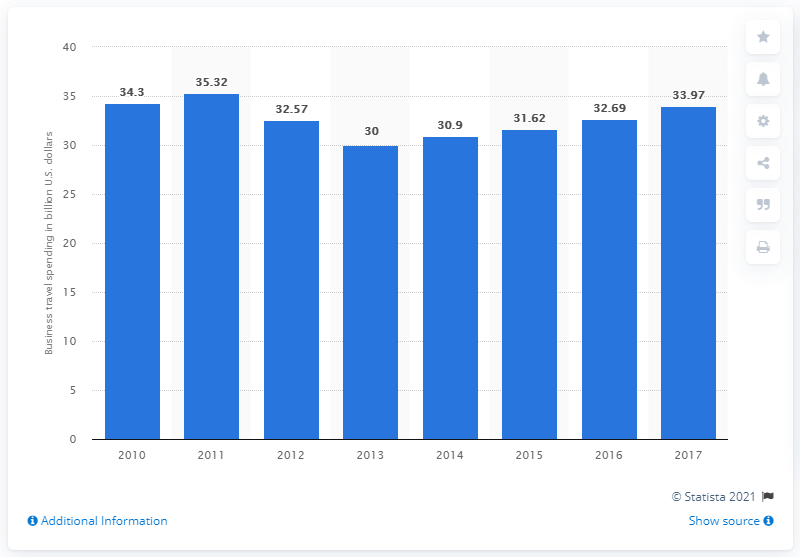Draw attention to some important aspects in this diagram. In 2017, Italy's business travel spending totaled 33.97. 